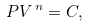Convert formula to latex. <formula><loc_0><loc_0><loc_500><loc_500>P V ^ { \, n } = C ,</formula> 